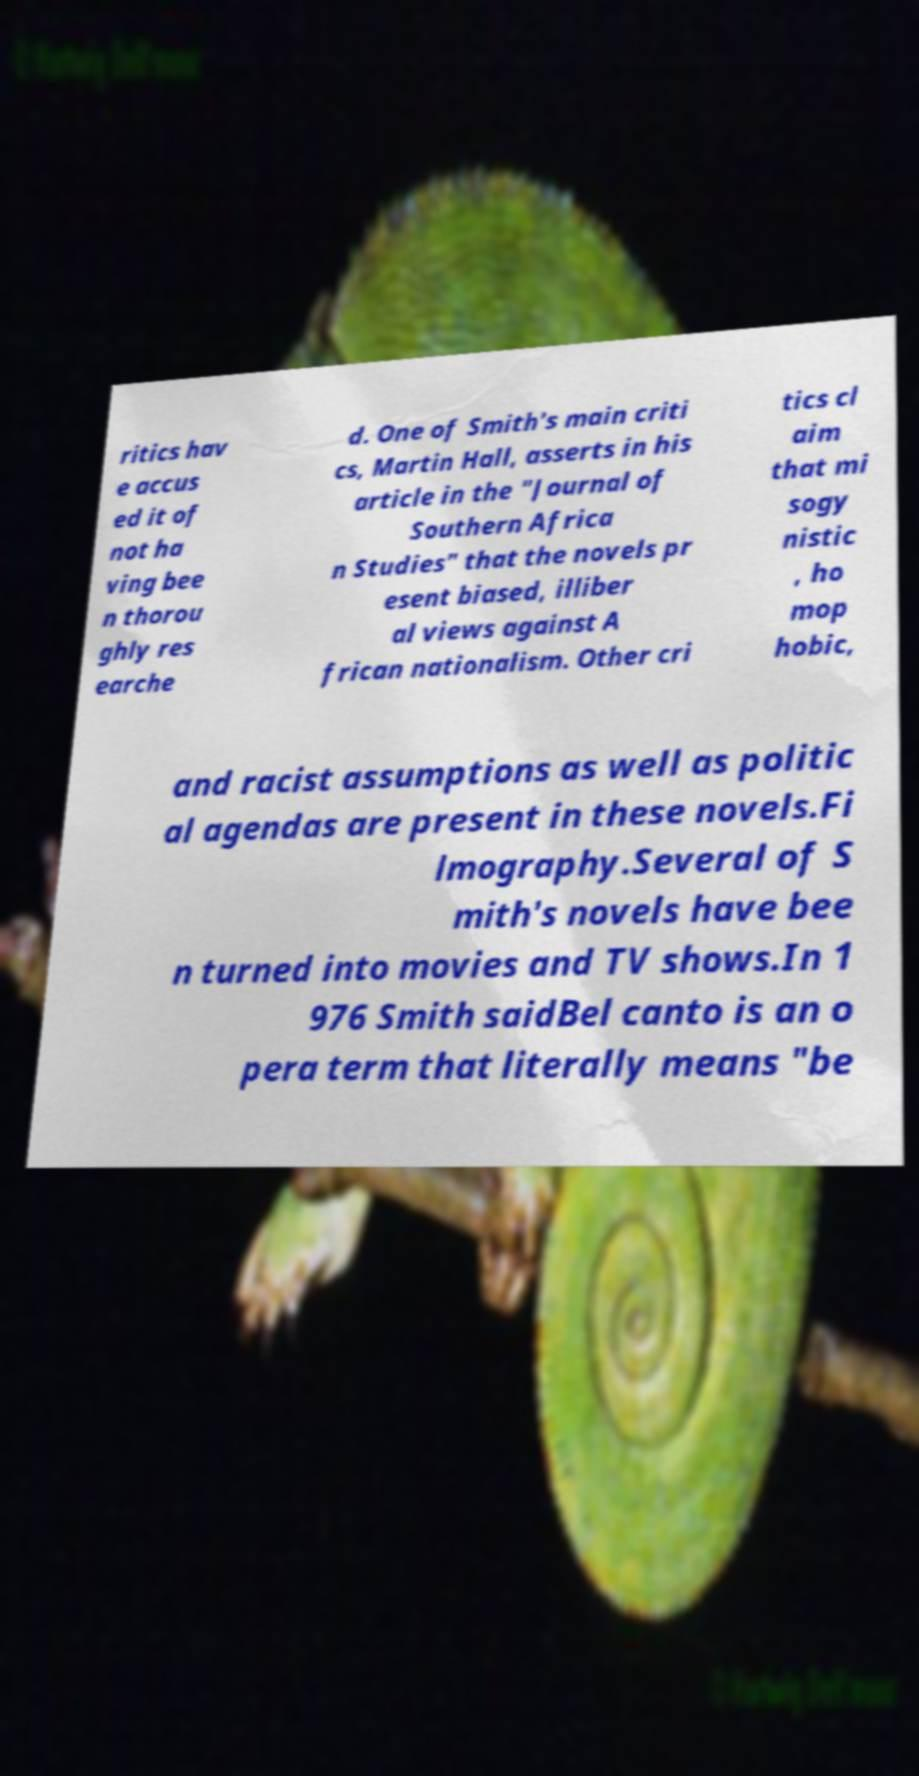What messages or text are displayed in this image? I need them in a readable, typed format. ritics hav e accus ed it of not ha ving bee n thorou ghly res earche d. One of Smith's main criti cs, Martin Hall, asserts in his article in the "Journal of Southern Africa n Studies" that the novels pr esent biased, illiber al views against A frican nationalism. Other cri tics cl aim that mi sogy nistic , ho mop hobic, and racist assumptions as well as politic al agendas are present in these novels.Fi lmography.Several of S mith's novels have bee n turned into movies and TV shows.In 1 976 Smith saidBel canto is an o pera term that literally means "be 